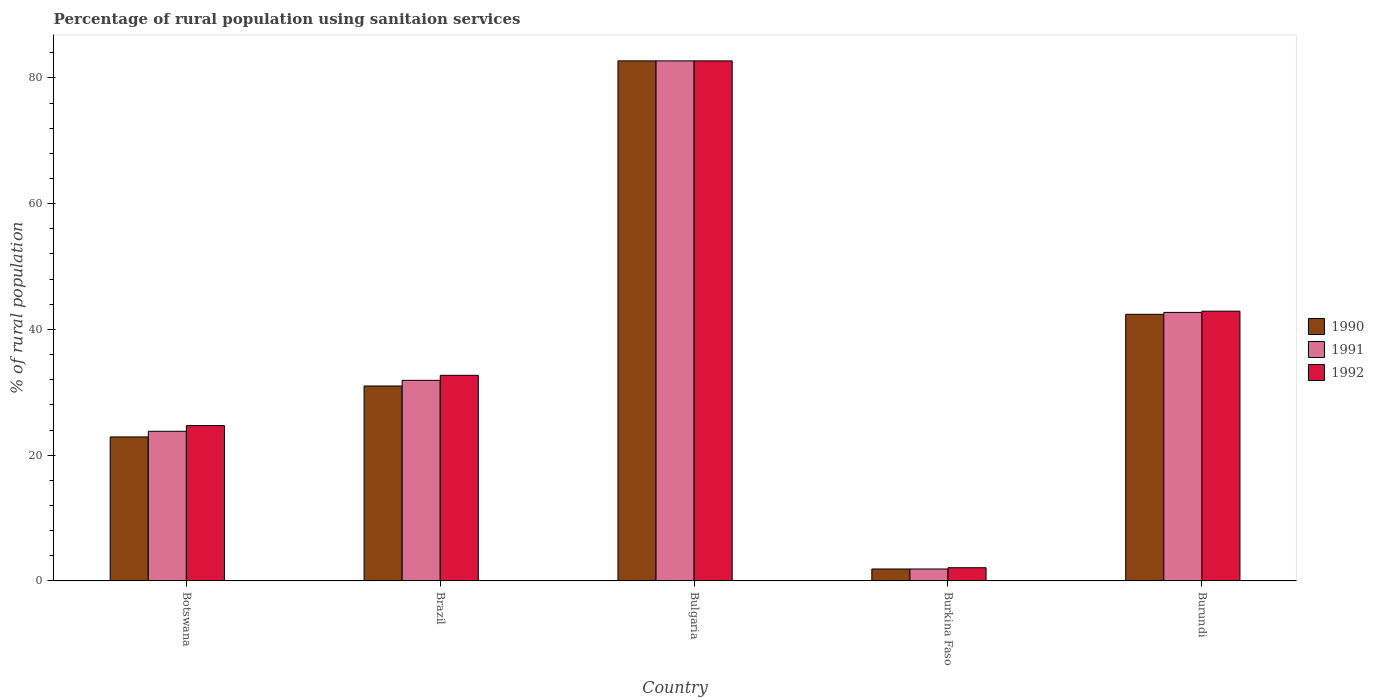Are the number of bars on each tick of the X-axis equal?
Provide a succinct answer. Yes. How many bars are there on the 1st tick from the right?
Provide a succinct answer. 3. What is the label of the 4th group of bars from the left?
Give a very brief answer. Burkina Faso. In how many cases, is the number of bars for a given country not equal to the number of legend labels?
Make the answer very short. 0. What is the percentage of rural population using sanitaion services in 1992 in Brazil?
Provide a short and direct response. 32.7. Across all countries, what is the maximum percentage of rural population using sanitaion services in 1991?
Offer a very short reply. 82.7. Across all countries, what is the minimum percentage of rural population using sanitaion services in 1991?
Make the answer very short. 1.9. In which country was the percentage of rural population using sanitaion services in 1992 minimum?
Your answer should be very brief. Burkina Faso. What is the total percentage of rural population using sanitaion services in 1991 in the graph?
Make the answer very short. 183. What is the difference between the percentage of rural population using sanitaion services in 1992 in Bulgaria and that in Burkina Faso?
Your answer should be very brief. 80.6. What is the difference between the percentage of rural population using sanitaion services in 1991 in Botswana and the percentage of rural population using sanitaion services in 1990 in Bulgaria?
Ensure brevity in your answer.  -58.9. What is the average percentage of rural population using sanitaion services in 1991 per country?
Offer a very short reply. 36.6. What is the difference between the percentage of rural population using sanitaion services of/in 1991 and percentage of rural population using sanitaion services of/in 1990 in Botswana?
Offer a terse response. 0.9. In how many countries, is the percentage of rural population using sanitaion services in 1992 greater than 72 %?
Keep it short and to the point. 1. What is the ratio of the percentage of rural population using sanitaion services in 1991 in Botswana to that in Burkina Faso?
Your answer should be very brief. 12.53. Is the percentage of rural population using sanitaion services in 1991 in Bulgaria less than that in Burundi?
Make the answer very short. No. What is the difference between the highest and the lowest percentage of rural population using sanitaion services in 1990?
Provide a succinct answer. 80.8. In how many countries, is the percentage of rural population using sanitaion services in 1992 greater than the average percentage of rural population using sanitaion services in 1992 taken over all countries?
Ensure brevity in your answer.  2. What is the difference between two consecutive major ticks on the Y-axis?
Provide a succinct answer. 20. Where does the legend appear in the graph?
Your response must be concise. Center right. What is the title of the graph?
Offer a very short reply. Percentage of rural population using sanitaion services. What is the label or title of the X-axis?
Give a very brief answer. Country. What is the label or title of the Y-axis?
Keep it short and to the point. % of rural population. What is the % of rural population of 1990 in Botswana?
Provide a short and direct response. 22.9. What is the % of rural population of 1991 in Botswana?
Provide a succinct answer. 23.8. What is the % of rural population of 1992 in Botswana?
Provide a short and direct response. 24.7. What is the % of rural population of 1990 in Brazil?
Keep it short and to the point. 31. What is the % of rural population in 1991 in Brazil?
Your response must be concise. 31.9. What is the % of rural population in 1992 in Brazil?
Give a very brief answer. 32.7. What is the % of rural population in 1990 in Bulgaria?
Offer a very short reply. 82.7. What is the % of rural population in 1991 in Bulgaria?
Offer a very short reply. 82.7. What is the % of rural population of 1992 in Bulgaria?
Your response must be concise. 82.7. What is the % of rural population of 1991 in Burkina Faso?
Your answer should be compact. 1.9. What is the % of rural population of 1990 in Burundi?
Offer a terse response. 42.4. What is the % of rural population of 1991 in Burundi?
Provide a succinct answer. 42.7. What is the % of rural population in 1992 in Burundi?
Offer a very short reply. 42.9. Across all countries, what is the maximum % of rural population of 1990?
Keep it short and to the point. 82.7. Across all countries, what is the maximum % of rural population of 1991?
Your answer should be very brief. 82.7. Across all countries, what is the maximum % of rural population in 1992?
Make the answer very short. 82.7. Across all countries, what is the minimum % of rural population of 1990?
Make the answer very short. 1.9. Across all countries, what is the minimum % of rural population of 1991?
Keep it short and to the point. 1.9. What is the total % of rural population of 1990 in the graph?
Provide a short and direct response. 180.9. What is the total % of rural population of 1991 in the graph?
Provide a succinct answer. 183. What is the total % of rural population of 1992 in the graph?
Keep it short and to the point. 185.1. What is the difference between the % of rural population in 1992 in Botswana and that in Brazil?
Offer a very short reply. -8. What is the difference between the % of rural population of 1990 in Botswana and that in Bulgaria?
Ensure brevity in your answer.  -59.8. What is the difference between the % of rural population of 1991 in Botswana and that in Bulgaria?
Provide a short and direct response. -58.9. What is the difference between the % of rural population in 1992 in Botswana and that in Bulgaria?
Ensure brevity in your answer.  -58. What is the difference between the % of rural population of 1990 in Botswana and that in Burkina Faso?
Provide a succinct answer. 21. What is the difference between the % of rural population of 1991 in Botswana and that in Burkina Faso?
Your response must be concise. 21.9. What is the difference between the % of rural population of 1992 in Botswana and that in Burkina Faso?
Provide a short and direct response. 22.6. What is the difference between the % of rural population of 1990 in Botswana and that in Burundi?
Make the answer very short. -19.5. What is the difference between the % of rural population in 1991 in Botswana and that in Burundi?
Your answer should be very brief. -18.9. What is the difference between the % of rural population of 1992 in Botswana and that in Burundi?
Your response must be concise. -18.2. What is the difference between the % of rural population of 1990 in Brazil and that in Bulgaria?
Ensure brevity in your answer.  -51.7. What is the difference between the % of rural population in 1991 in Brazil and that in Bulgaria?
Your response must be concise. -50.8. What is the difference between the % of rural population in 1990 in Brazil and that in Burkina Faso?
Make the answer very short. 29.1. What is the difference between the % of rural population in 1991 in Brazil and that in Burkina Faso?
Provide a succinct answer. 30. What is the difference between the % of rural population in 1992 in Brazil and that in Burkina Faso?
Your answer should be very brief. 30.6. What is the difference between the % of rural population in 1992 in Brazil and that in Burundi?
Offer a very short reply. -10.2. What is the difference between the % of rural population in 1990 in Bulgaria and that in Burkina Faso?
Offer a terse response. 80.8. What is the difference between the % of rural population of 1991 in Bulgaria and that in Burkina Faso?
Offer a very short reply. 80.8. What is the difference between the % of rural population of 1992 in Bulgaria and that in Burkina Faso?
Provide a succinct answer. 80.6. What is the difference between the % of rural population in 1990 in Bulgaria and that in Burundi?
Keep it short and to the point. 40.3. What is the difference between the % of rural population in 1992 in Bulgaria and that in Burundi?
Provide a short and direct response. 39.8. What is the difference between the % of rural population in 1990 in Burkina Faso and that in Burundi?
Your answer should be compact. -40.5. What is the difference between the % of rural population of 1991 in Burkina Faso and that in Burundi?
Your answer should be very brief. -40.8. What is the difference between the % of rural population of 1992 in Burkina Faso and that in Burundi?
Ensure brevity in your answer.  -40.8. What is the difference between the % of rural population in 1990 in Botswana and the % of rural population in 1992 in Brazil?
Offer a terse response. -9.8. What is the difference between the % of rural population in 1991 in Botswana and the % of rural population in 1992 in Brazil?
Your answer should be very brief. -8.9. What is the difference between the % of rural population in 1990 in Botswana and the % of rural population in 1991 in Bulgaria?
Your answer should be very brief. -59.8. What is the difference between the % of rural population in 1990 in Botswana and the % of rural population in 1992 in Bulgaria?
Offer a terse response. -59.8. What is the difference between the % of rural population in 1991 in Botswana and the % of rural population in 1992 in Bulgaria?
Offer a very short reply. -58.9. What is the difference between the % of rural population of 1990 in Botswana and the % of rural population of 1992 in Burkina Faso?
Provide a succinct answer. 20.8. What is the difference between the % of rural population in 1991 in Botswana and the % of rural population in 1992 in Burkina Faso?
Offer a terse response. 21.7. What is the difference between the % of rural population in 1990 in Botswana and the % of rural population in 1991 in Burundi?
Offer a very short reply. -19.8. What is the difference between the % of rural population in 1990 in Botswana and the % of rural population in 1992 in Burundi?
Your answer should be very brief. -20. What is the difference between the % of rural population of 1991 in Botswana and the % of rural population of 1992 in Burundi?
Provide a short and direct response. -19.1. What is the difference between the % of rural population in 1990 in Brazil and the % of rural population in 1991 in Bulgaria?
Give a very brief answer. -51.7. What is the difference between the % of rural population of 1990 in Brazil and the % of rural population of 1992 in Bulgaria?
Your answer should be compact. -51.7. What is the difference between the % of rural population in 1991 in Brazil and the % of rural population in 1992 in Bulgaria?
Offer a terse response. -50.8. What is the difference between the % of rural population in 1990 in Brazil and the % of rural population in 1991 in Burkina Faso?
Provide a succinct answer. 29.1. What is the difference between the % of rural population of 1990 in Brazil and the % of rural population of 1992 in Burkina Faso?
Your answer should be very brief. 28.9. What is the difference between the % of rural population in 1991 in Brazil and the % of rural population in 1992 in Burkina Faso?
Provide a short and direct response. 29.8. What is the difference between the % of rural population in 1990 in Brazil and the % of rural population in 1991 in Burundi?
Provide a succinct answer. -11.7. What is the difference between the % of rural population in 1990 in Brazil and the % of rural population in 1992 in Burundi?
Your answer should be very brief. -11.9. What is the difference between the % of rural population in 1990 in Bulgaria and the % of rural population in 1991 in Burkina Faso?
Ensure brevity in your answer.  80.8. What is the difference between the % of rural population of 1990 in Bulgaria and the % of rural population of 1992 in Burkina Faso?
Ensure brevity in your answer.  80.6. What is the difference between the % of rural population of 1991 in Bulgaria and the % of rural population of 1992 in Burkina Faso?
Keep it short and to the point. 80.6. What is the difference between the % of rural population of 1990 in Bulgaria and the % of rural population of 1991 in Burundi?
Keep it short and to the point. 40. What is the difference between the % of rural population in 1990 in Bulgaria and the % of rural population in 1992 in Burundi?
Provide a succinct answer. 39.8. What is the difference between the % of rural population of 1991 in Bulgaria and the % of rural population of 1992 in Burundi?
Keep it short and to the point. 39.8. What is the difference between the % of rural population in 1990 in Burkina Faso and the % of rural population in 1991 in Burundi?
Offer a very short reply. -40.8. What is the difference between the % of rural population in 1990 in Burkina Faso and the % of rural population in 1992 in Burundi?
Provide a short and direct response. -41. What is the difference between the % of rural population in 1991 in Burkina Faso and the % of rural population in 1992 in Burundi?
Offer a terse response. -41. What is the average % of rural population in 1990 per country?
Your answer should be very brief. 36.18. What is the average % of rural population in 1991 per country?
Your answer should be compact. 36.6. What is the average % of rural population in 1992 per country?
Your response must be concise. 37.02. What is the difference between the % of rural population in 1991 and % of rural population in 1992 in Botswana?
Your response must be concise. -0.9. What is the difference between the % of rural population in 1991 and % of rural population in 1992 in Brazil?
Your answer should be very brief. -0.8. What is the difference between the % of rural population in 1990 and % of rural population in 1992 in Bulgaria?
Offer a very short reply. 0. What is the difference between the % of rural population of 1990 and % of rural population of 1992 in Burkina Faso?
Provide a short and direct response. -0.2. What is the difference between the % of rural population in 1990 and % of rural population in 1992 in Burundi?
Provide a short and direct response. -0.5. What is the ratio of the % of rural population in 1990 in Botswana to that in Brazil?
Provide a short and direct response. 0.74. What is the ratio of the % of rural population of 1991 in Botswana to that in Brazil?
Your response must be concise. 0.75. What is the ratio of the % of rural population of 1992 in Botswana to that in Brazil?
Make the answer very short. 0.76. What is the ratio of the % of rural population in 1990 in Botswana to that in Bulgaria?
Offer a very short reply. 0.28. What is the ratio of the % of rural population of 1991 in Botswana to that in Bulgaria?
Give a very brief answer. 0.29. What is the ratio of the % of rural population of 1992 in Botswana to that in Bulgaria?
Offer a very short reply. 0.3. What is the ratio of the % of rural population in 1990 in Botswana to that in Burkina Faso?
Ensure brevity in your answer.  12.05. What is the ratio of the % of rural population in 1991 in Botswana to that in Burkina Faso?
Provide a succinct answer. 12.53. What is the ratio of the % of rural population of 1992 in Botswana to that in Burkina Faso?
Your answer should be very brief. 11.76. What is the ratio of the % of rural population of 1990 in Botswana to that in Burundi?
Offer a very short reply. 0.54. What is the ratio of the % of rural population of 1991 in Botswana to that in Burundi?
Offer a terse response. 0.56. What is the ratio of the % of rural population of 1992 in Botswana to that in Burundi?
Offer a terse response. 0.58. What is the ratio of the % of rural population of 1990 in Brazil to that in Bulgaria?
Provide a succinct answer. 0.37. What is the ratio of the % of rural population in 1991 in Brazil to that in Bulgaria?
Offer a very short reply. 0.39. What is the ratio of the % of rural population in 1992 in Brazil to that in Bulgaria?
Give a very brief answer. 0.4. What is the ratio of the % of rural population of 1990 in Brazil to that in Burkina Faso?
Make the answer very short. 16.32. What is the ratio of the % of rural population of 1991 in Brazil to that in Burkina Faso?
Provide a succinct answer. 16.79. What is the ratio of the % of rural population of 1992 in Brazil to that in Burkina Faso?
Offer a terse response. 15.57. What is the ratio of the % of rural population in 1990 in Brazil to that in Burundi?
Offer a very short reply. 0.73. What is the ratio of the % of rural population in 1991 in Brazil to that in Burundi?
Ensure brevity in your answer.  0.75. What is the ratio of the % of rural population of 1992 in Brazil to that in Burundi?
Your answer should be very brief. 0.76. What is the ratio of the % of rural population of 1990 in Bulgaria to that in Burkina Faso?
Your response must be concise. 43.53. What is the ratio of the % of rural population in 1991 in Bulgaria to that in Burkina Faso?
Provide a short and direct response. 43.53. What is the ratio of the % of rural population of 1992 in Bulgaria to that in Burkina Faso?
Keep it short and to the point. 39.38. What is the ratio of the % of rural population of 1990 in Bulgaria to that in Burundi?
Keep it short and to the point. 1.95. What is the ratio of the % of rural population of 1991 in Bulgaria to that in Burundi?
Give a very brief answer. 1.94. What is the ratio of the % of rural population in 1992 in Bulgaria to that in Burundi?
Provide a succinct answer. 1.93. What is the ratio of the % of rural population of 1990 in Burkina Faso to that in Burundi?
Your response must be concise. 0.04. What is the ratio of the % of rural population in 1991 in Burkina Faso to that in Burundi?
Offer a terse response. 0.04. What is the ratio of the % of rural population of 1992 in Burkina Faso to that in Burundi?
Offer a very short reply. 0.05. What is the difference between the highest and the second highest % of rural population in 1990?
Your answer should be compact. 40.3. What is the difference between the highest and the second highest % of rural population in 1992?
Ensure brevity in your answer.  39.8. What is the difference between the highest and the lowest % of rural population in 1990?
Ensure brevity in your answer.  80.8. What is the difference between the highest and the lowest % of rural population in 1991?
Your response must be concise. 80.8. What is the difference between the highest and the lowest % of rural population of 1992?
Offer a very short reply. 80.6. 